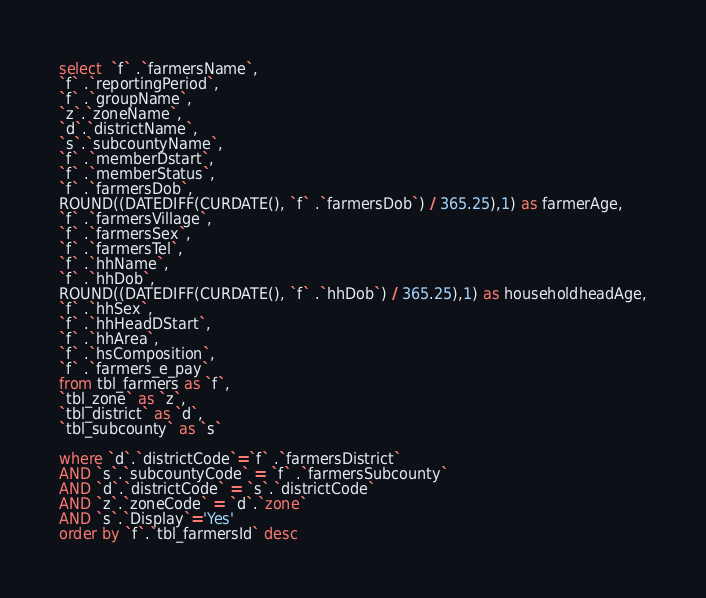<code> <loc_0><loc_0><loc_500><loc_500><_SQL_>select  `f` .`farmersName`,
`f` .`reportingPeriod`,
`f` .`groupName`,
`z`.`zoneName`,
`d`.`districtName`,
`s`.`subcountyName`,
`f` .`memberDstart`, 
`f` .`memberStatus`,
`f` .`farmersDob`, 
ROUND((DATEDIFF(CURDATE(), `f` .`farmersDob`) / 365.25),1) as farmerAge,
`f` .`farmersVillage`,
`f` .`farmersSex`,
`f` .`farmersTel`,
`f` .`hhName`,
`f` .`hhDob`,
ROUND((DATEDIFF(CURDATE(), `f` .`hhDob`) / 365.25),1) as householdheadAge,
`f` .`hhSex`, 
`f` .`hhHeadDStart`, 
`f` .`hhArea`,
`f` .`hsComposition`, 
`f` .`farmers_e_pay`
from tbl_farmers as `f`,
`tbl_zone` as `z`,
`tbl_district` as `d`,
`tbl_subcounty` as `s` 

where `d`.`districtCode`=`f` .`farmersDistrict`
AND `s`.`subcountyCode` = `f` .`farmersSubcounty`
AND `d`.`districtCode` = `s`.`districtCode`
AND `z`.`zoneCode` = `d`.`zone`
AND `s`.`Display`='Yes' 
order by `f`.`tbl_farmersId` desc
</code> 